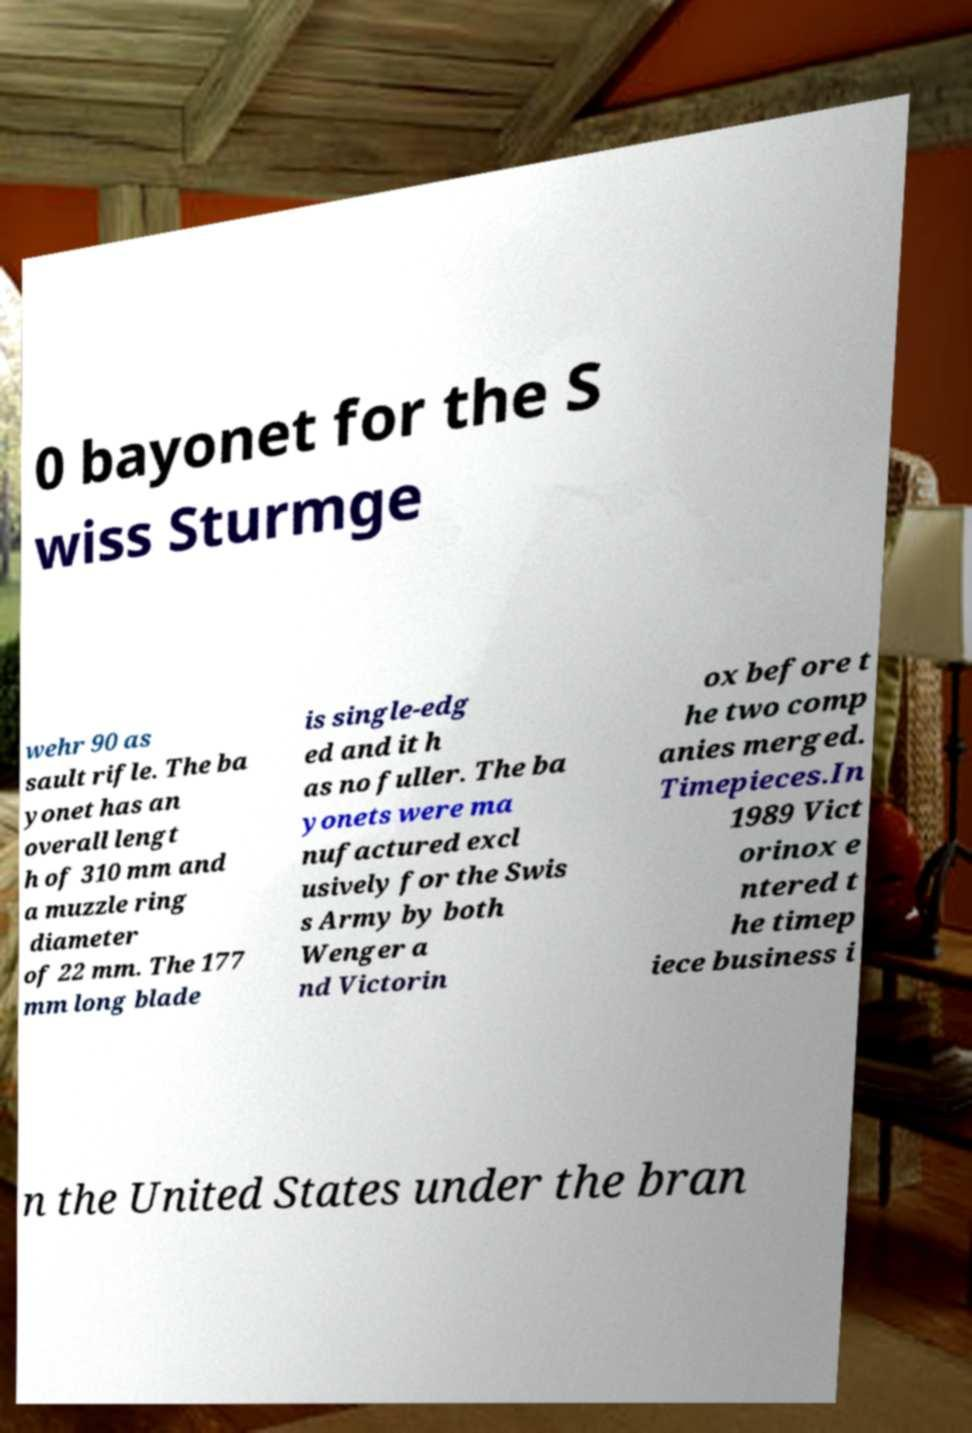There's text embedded in this image that I need extracted. Can you transcribe it verbatim? 0 bayonet for the S wiss Sturmge wehr 90 as sault rifle. The ba yonet has an overall lengt h of 310 mm and a muzzle ring diameter of 22 mm. The 177 mm long blade is single-edg ed and it h as no fuller. The ba yonets were ma nufactured excl usively for the Swis s Army by both Wenger a nd Victorin ox before t he two comp anies merged. Timepieces.In 1989 Vict orinox e ntered t he timep iece business i n the United States under the bran 